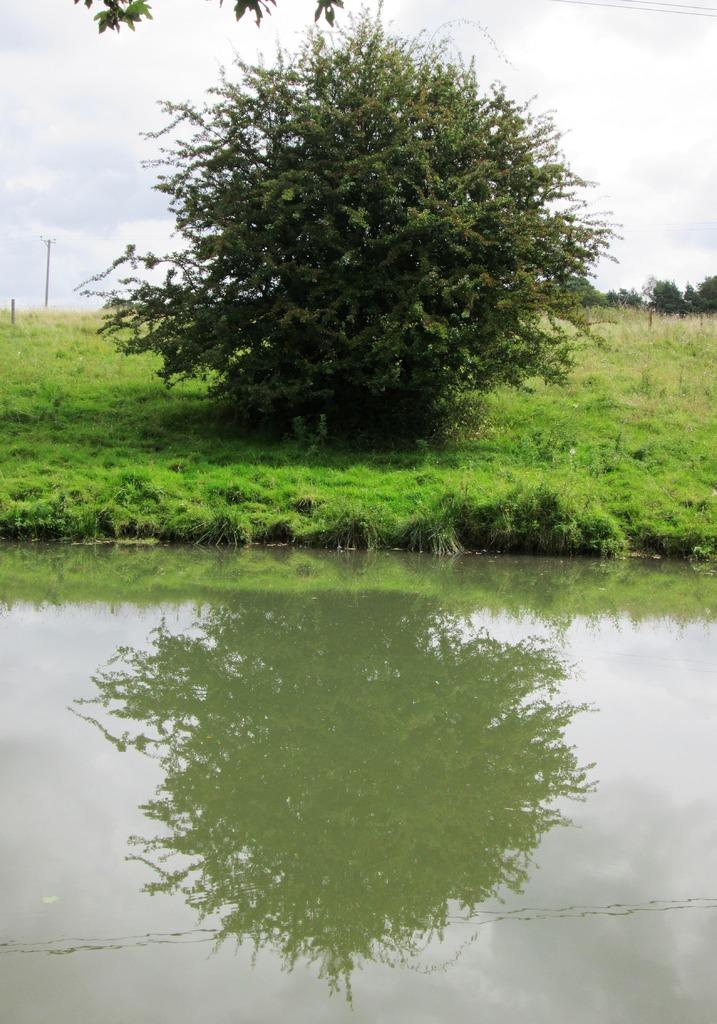What type of natural vegetation can be seen in the image? There are trees in the image. What objects are on the ground in the image? There are poles on the ground in the image. What can be seen at the bottom of the image? There is water visible at the bottom of the image. How many beads are hanging from the trees in the image? There are no beads present in the image; it features trees, poles, and water. What type of scale can be seen on the poles in the image? There is no scale present on the poles in the image. 